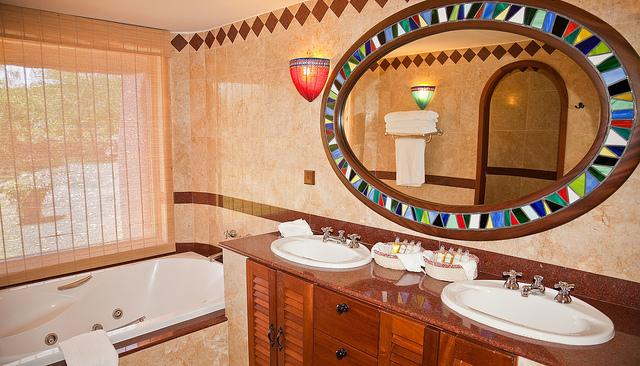Why does the tub have round silver objects on it? Please explain your reasoning. whirlpool. The tub has a whirlpool. 